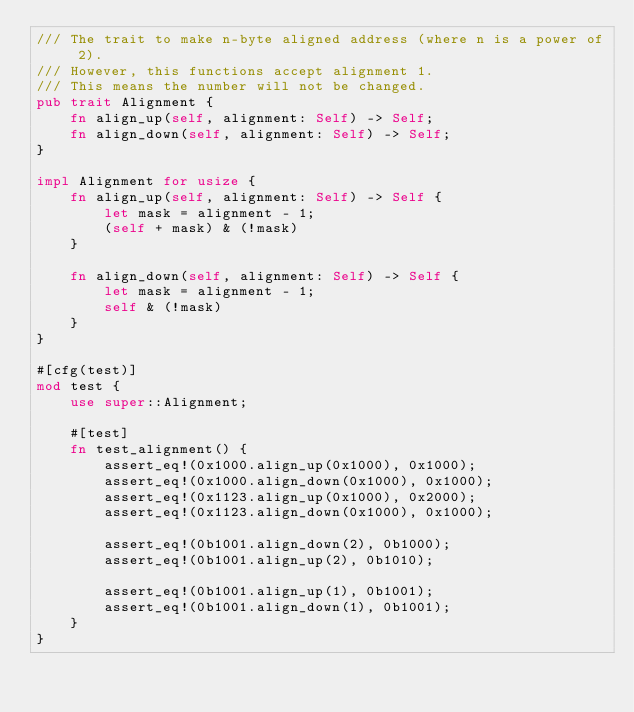<code> <loc_0><loc_0><loc_500><loc_500><_Rust_>/// The trait to make n-byte aligned address (where n is a power of 2).
/// However, this functions accept alignment 1.
/// This means the number will not be changed.
pub trait Alignment {
    fn align_up(self, alignment: Self) -> Self;
    fn align_down(self, alignment: Self) -> Self;
}

impl Alignment for usize {
    fn align_up(self, alignment: Self) -> Self {
        let mask = alignment - 1;
        (self + mask) & (!mask)
    }

    fn align_down(self, alignment: Self) -> Self {
        let mask = alignment - 1;
        self & (!mask)
    }
}

#[cfg(test)]
mod test {
    use super::Alignment;

    #[test]
    fn test_alignment() {
        assert_eq!(0x1000.align_up(0x1000), 0x1000);
        assert_eq!(0x1000.align_down(0x1000), 0x1000);
        assert_eq!(0x1123.align_up(0x1000), 0x2000);
        assert_eq!(0x1123.align_down(0x1000), 0x1000);

        assert_eq!(0b1001.align_down(2), 0b1000);
        assert_eq!(0b1001.align_up(2), 0b1010);

        assert_eq!(0b1001.align_up(1), 0b1001);
        assert_eq!(0b1001.align_down(1), 0b1001);
    }
}
</code> 